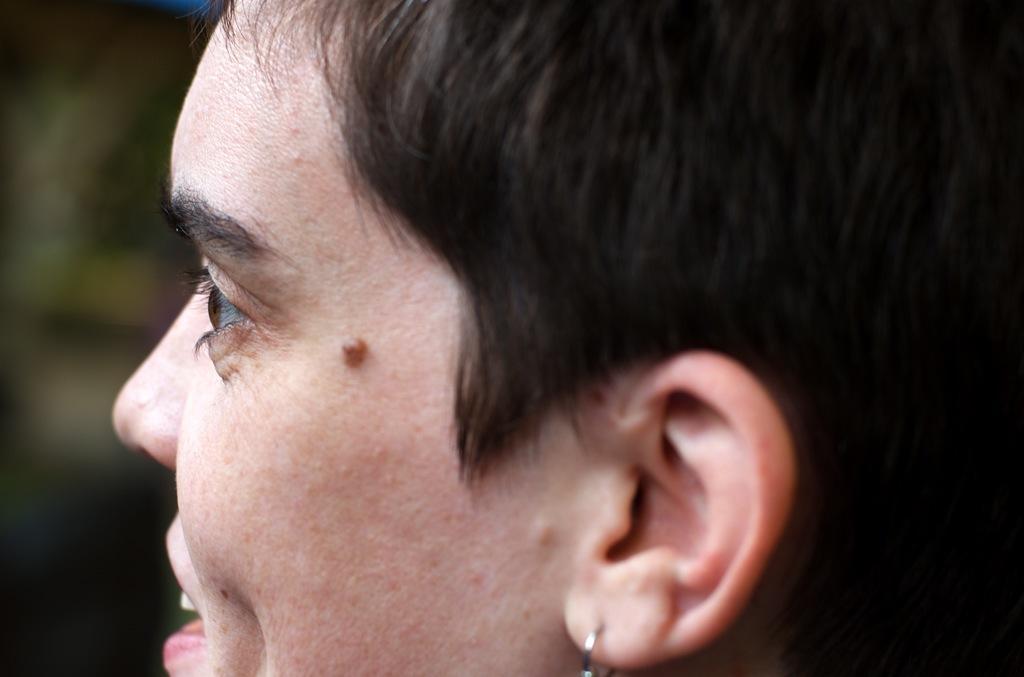Describe this image in one or two sentences. In this image in front there is a person and the background of the image is blur. 